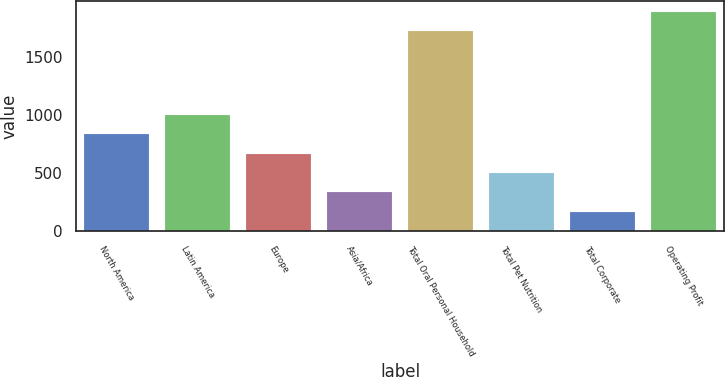<chart> <loc_0><loc_0><loc_500><loc_500><bar_chart><fcel>North America<fcel>Latin America<fcel>Europe<fcel>Asia/Africa<fcel>Total Oral Personal Household<fcel>Total Pet Nutrition<fcel>Total Corporate<fcel>Operating Profit<nl><fcel>833.28<fcel>1000.2<fcel>666.36<fcel>332.52<fcel>1718.3<fcel>499.44<fcel>165.6<fcel>1885.22<nl></chart> 